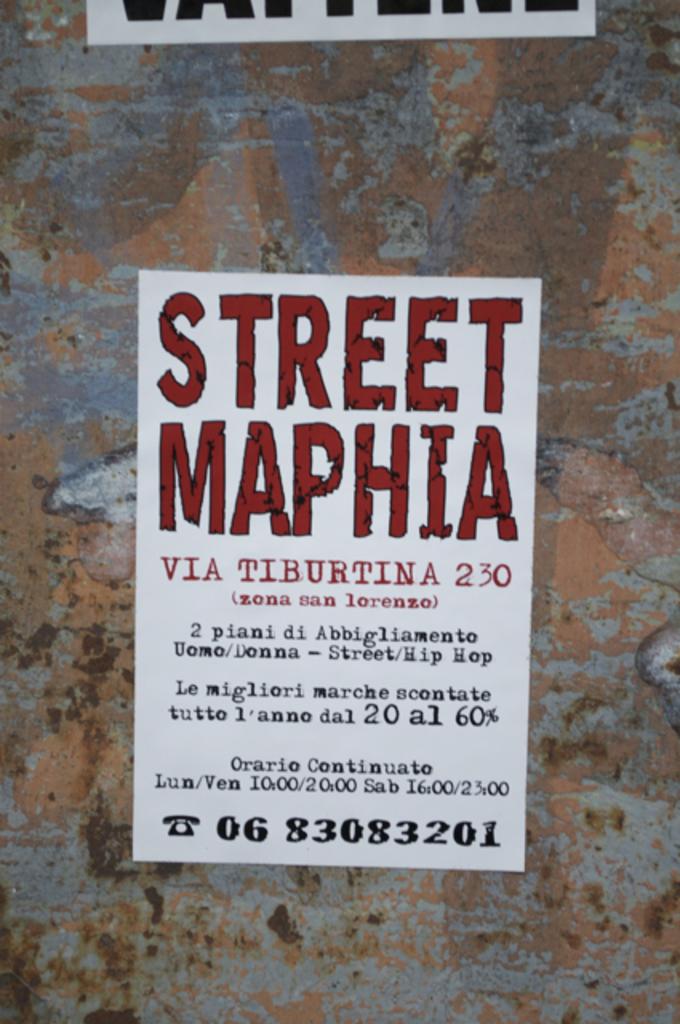What is the advert bout?
Ensure brevity in your answer.  Street maphia. What is the number on the bottom?
Make the answer very short. 0683083201. 